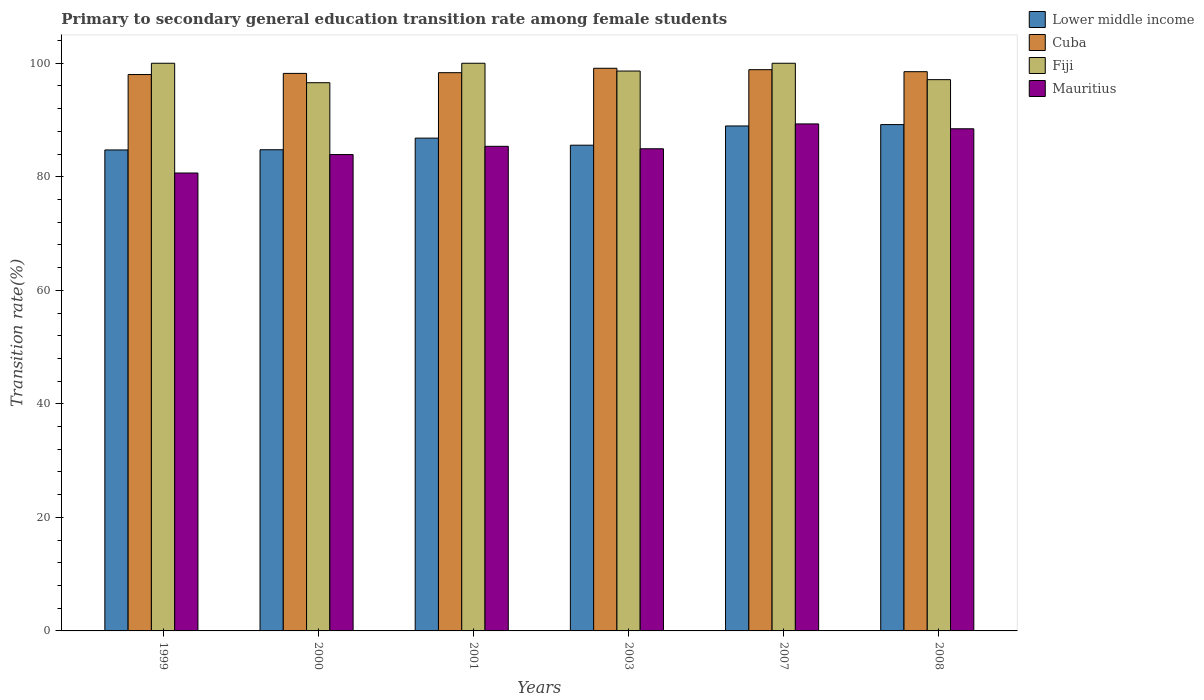How many groups of bars are there?
Keep it short and to the point. 6. Are the number of bars per tick equal to the number of legend labels?
Give a very brief answer. Yes. Are the number of bars on each tick of the X-axis equal?
Provide a short and direct response. Yes. What is the label of the 6th group of bars from the left?
Your response must be concise. 2008. In how many cases, is the number of bars for a given year not equal to the number of legend labels?
Provide a short and direct response. 0. What is the transition rate in Lower middle income in 2008?
Your answer should be compact. 89.2. Across all years, what is the maximum transition rate in Cuba?
Your answer should be very brief. 99.12. Across all years, what is the minimum transition rate in Mauritius?
Ensure brevity in your answer.  80.67. In which year was the transition rate in Lower middle income minimum?
Give a very brief answer. 1999. What is the total transition rate in Cuba in the graph?
Make the answer very short. 591.07. What is the difference between the transition rate in Mauritius in 1999 and that in 2007?
Offer a very short reply. -8.65. What is the difference between the transition rate in Lower middle income in 2001 and the transition rate in Fiji in 1999?
Keep it short and to the point. -13.19. What is the average transition rate in Fiji per year?
Offer a very short reply. 98.72. In the year 2003, what is the difference between the transition rate in Fiji and transition rate in Cuba?
Make the answer very short. -0.49. In how many years, is the transition rate in Lower middle income greater than 60 %?
Offer a terse response. 6. What is the ratio of the transition rate in Fiji in 2000 to that in 2008?
Keep it short and to the point. 0.99. What is the difference between the highest and the second highest transition rate in Mauritius?
Your answer should be compact. 0.86. What is the difference between the highest and the lowest transition rate in Lower middle income?
Offer a very short reply. 4.47. What does the 2nd bar from the left in 2003 represents?
Keep it short and to the point. Cuba. What does the 3rd bar from the right in 2003 represents?
Offer a terse response. Cuba. Is it the case that in every year, the sum of the transition rate in Fiji and transition rate in Cuba is greater than the transition rate in Lower middle income?
Offer a terse response. Yes. How many years are there in the graph?
Provide a short and direct response. 6. What is the difference between two consecutive major ticks on the Y-axis?
Provide a short and direct response. 20. Does the graph contain any zero values?
Your answer should be compact. No. Does the graph contain grids?
Your response must be concise. No. Where does the legend appear in the graph?
Make the answer very short. Top right. How many legend labels are there?
Keep it short and to the point. 4. How are the legend labels stacked?
Your answer should be compact. Vertical. What is the title of the graph?
Make the answer very short. Primary to secondary general education transition rate among female students. What is the label or title of the Y-axis?
Your answer should be compact. Transition rate(%). What is the Transition rate(%) of Lower middle income in 1999?
Ensure brevity in your answer.  84.73. What is the Transition rate(%) of Cuba in 1999?
Give a very brief answer. 98.01. What is the Transition rate(%) of Fiji in 1999?
Ensure brevity in your answer.  100. What is the Transition rate(%) of Mauritius in 1999?
Ensure brevity in your answer.  80.67. What is the Transition rate(%) in Lower middle income in 2000?
Offer a very short reply. 84.76. What is the Transition rate(%) in Cuba in 2000?
Your answer should be very brief. 98.21. What is the Transition rate(%) in Fiji in 2000?
Ensure brevity in your answer.  96.57. What is the Transition rate(%) of Mauritius in 2000?
Make the answer very short. 83.92. What is the Transition rate(%) in Lower middle income in 2001?
Keep it short and to the point. 86.81. What is the Transition rate(%) in Cuba in 2001?
Ensure brevity in your answer.  98.34. What is the Transition rate(%) of Mauritius in 2001?
Keep it short and to the point. 85.37. What is the Transition rate(%) of Lower middle income in 2003?
Give a very brief answer. 85.56. What is the Transition rate(%) of Cuba in 2003?
Offer a very short reply. 99.12. What is the Transition rate(%) in Fiji in 2003?
Make the answer very short. 98.63. What is the Transition rate(%) in Mauritius in 2003?
Ensure brevity in your answer.  84.94. What is the Transition rate(%) in Lower middle income in 2007?
Give a very brief answer. 88.96. What is the Transition rate(%) in Cuba in 2007?
Keep it short and to the point. 98.87. What is the Transition rate(%) in Fiji in 2007?
Your answer should be compact. 100. What is the Transition rate(%) in Mauritius in 2007?
Provide a short and direct response. 89.32. What is the Transition rate(%) in Lower middle income in 2008?
Ensure brevity in your answer.  89.2. What is the Transition rate(%) of Cuba in 2008?
Keep it short and to the point. 98.52. What is the Transition rate(%) in Fiji in 2008?
Offer a terse response. 97.11. What is the Transition rate(%) in Mauritius in 2008?
Provide a short and direct response. 88.46. Across all years, what is the maximum Transition rate(%) of Lower middle income?
Provide a short and direct response. 89.2. Across all years, what is the maximum Transition rate(%) in Cuba?
Your response must be concise. 99.12. Across all years, what is the maximum Transition rate(%) of Mauritius?
Provide a succinct answer. 89.32. Across all years, what is the minimum Transition rate(%) of Lower middle income?
Keep it short and to the point. 84.73. Across all years, what is the minimum Transition rate(%) of Cuba?
Make the answer very short. 98.01. Across all years, what is the minimum Transition rate(%) of Fiji?
Give a very brief answer. 96.57. Across all years, what is the minimum Transition rate(%) of Mauritius?
Offer a very short reply. 80.67. What is the total Transition rate(%) of Lower middle income in the graph?
Keep it short and to the point. 520.02. What is the total Transition rate(%) of Cuba in the graph?
Provide a short and direct response. 591.07. What is the total Transition rate(%) of Fiji in the graph?
Give a very brief answer. 592.31. What is the total Transition rate(%) of Mauritius in the graph?
Your answer should be very brief. 512.66. What is the difference between the Transition rate(%) in Lower middle income in 1999 and that in 2000?
Offer a terse response. -0.04. What is the difference between the Transition rate(%) in Cuba in 1999 and that in 2000?
Your response must be concise. -0.2. What is the difference between the Transition rate(%) of Fiji in 1999 and that in 2000?
Keep it short and to the point. 3.43. What is the difference between the Transition rate(%) in Mauritius in 1999 and that in 2000?
Provide a short and direct response. -3.25. What is the difference between the Transition rate(%) of Lower middle income in 1999 and that in 2001?
Provide a succinct answer. -2.08. What is the difference between the Transition rate(%) of Cuba in 1999 and that in 2001?
Ensure brevity in your answer.  -0.33. What is the difference between the Transition rate(%) in Mauritius in 1999 and that in 2001?
Keep it short and to the point. -4.7. What is the difference between the Transition rate(%) of Lower middle income in 1999 and that in 2003?
Provide a short and direct response. -0.84. What is the difference between the Transition rate(%) of Cuba in 1999 and that in 2003?
Provide a succinct answer. -1.11. What is the difference between the Transition rate(%) of Fiji in 1999 and that in 2003?
Ensure brevity in your answer.  1.37. What is the difference between the Transition rate(%) in Mauritius in 1999 and that in 2003?
Make the answer very short. -4.27. What is the difference between the Transition rate(%) in Lower middle income in 1999 and that in 2007?
Your answer should be compact. -4.23. What is the difference between the Transition rate(%) of Cuba in 1999 and that in 2007?
Provide a short and direct response. -0.86. What is the difference between the Transition rate(%) of Fiji in 1999 and that in 2007?
Keep it short and to the point. 0. What is the difference between the Transition rate(%) in Mauritius in 1999 and that in 2007?
Give a very brief answer. -8.65. What is the difference between the Transition rate(%) of Lower middle income in 1999 and that in 2008?
Provide a succinct answer. -4.47. What is the difference between the Transition rate(%) in Cuba in 1999 and that in 2008?
Your response must be concise. -0.5. What is the difference between the Transition rate(%) in Fiji in 1999 and that in 2008?
Your answer should be very brief. 2.89. What is the difference between the Transition rate(%) of Mauritius in 1999 and that in 2008?
Ensure brevity in your answer.  -7.79. What is the difference between the Transition rate(%) of Lower middle income in 2000 and that in 2001?
Provide a short and direct response. -2.05. What is the difference between the Transition rate(%) of Cuba in 2000 and that in 2001?
Your response must be concise. -0.13. What is the difference between the Transition rate(%) in Fiji in 2000 and that in 2001?
Offer a terse response. -3.43. What is the difference between the Transition rate(%) in Mauritius in 2000 and that in 2001?
Provide a succinct answer. -1.45. What is the difference between the Transition rate(%) in Lower middle income in 2000 and that in 2003?
Make the answer very short. -0.8. What is the difference between the Transition rate(%) in Cuba in 2000 and that in 2003?
Keep it short and to the point. -0.9. What is the difference between the Transition rate(%) in Fiji in 2000 and that in 2003?
Ensure brevity in your answer.  -2.06. What is the difference between the Transition rate(%) of Mauritius in 2000 and that in 2003?
Offer a very short reply. -1.02. What is the difference between the Transition rate(%) in Lower middle income in 2000 and that in 2007?
Your response must be concise. -4.19. What is the difference between the Transition rate(%) of Cuba in 2000 and that in 2007?
Keep it short and to the point. -0.66. What is the difference between the Transition rate(%) in Fiji in 2000 and that in 2007?
Keep it short and to the point. -3.43. What is the difference between the Transition rate(%) of Mauritius in 2000 and that in 2007?
Provide a short and direct response. -5.4. What is the difference between the Transition rate(%) in Lower middle income in 2000 and that in 2008?
Give a very brief answer. -4.43. What is the difference between the Transition rate(%) in Cuba in 2000 and that in 2008?
Your answer should be compact. -0.3. What is the difference between the Transition rate(%) in Fiji in 2000 and that in 2008?
Offer a very short reply. -0.54. What is the difference between the Transition rate(%) of Mauritius in 2000 and that in 2008?
Make the answer very short. -4.54. What is the difference between the Transition rate(%) of Lower middle income in 2001 and that in 2003?
Your answer should be compact. 1.25. What is the difference between the Transition rate(%) in Cuba in 2001 and that in 2003?
Your answer should be very brief. -0.78. What is the difference between the Transition rate(%) of Fiji in 2001 and that in 2003?
Give a very brief answer. 1.37. What is the difference between the Transition rate(%) of Mauritius in 2001 and that in 2003?
Ensure brevity in your answer.  0.43. What is the difference between the Transition rate(%) of Lower middle income in 2001 and that in 2007?
Your answer should be compact. -2.14. What is the difference between the Transition rate(%) in Cuba in 2001 and that in 2007?
Keep it short and to the point. -0.53. What is the difference between the Transition rate(%) of Fiji in 2001 and that in 2007?
Give a very brief answer. 0. What is the difference between the Transition rate(%) of Mauritius in 2001 and that in 2007?
Offer a terse response. -3.95. What is the difference between the Transition rate(%) of Lower middle income in 2001 and that in 2008?
Keep it short and to the point. -2.39. What is the difference between the Transition rate(%) of Cuba in 2001 and that in 2008?
Provide a succinct answer. -0.18. What is the difference between the Transition rate(%) in Fiji in 2001 and that in 2008?
Offer a terse response. 2.89. What is the difference between the Transition rate(%) of Mauritius in 2001 and that in 2008?
Give a very brief answer. -3.09. What is the difference between the Transition rate(%) in Lower middle income in 2003 and that in 2007?
Offer a terse response. -3.39. What is the difference between the Transition rate(%) of Cuba in 2003 and that in 2007?
Your answer should be very brief. 0.25. What is the difference between the Transition rate(%) of Fiji in 2003 and that in 2007?
Your answer should be very brief. -1.37. What is the difference between the Transition rate(%) in Mauritius in 2003 and that in 2007?
Offer a very short reply. -4.38. What is the difference between the Transition rate(%) in Lower middle income in 2003 and that in 2008?
Your answer should be very brief. -3.63. What is the difference between the Transition rate(%) in Cuba in 2003 and that in 2008?
Ensure brevity in your answer.  0.6. What is the difference between the Transition rate(%) of Fiji in 2003 and that in 2008?
Your answer should be very brief. 1.52. What is the difference between the Transition rate(%) of Mauritius in 2003 and that in 2008?
Provide a succinct answer. -3.52. What is the difference between the Transition rate(%) of Lower middle income in 2007 and that in 2008?
Your response must be concise. -0.24. What is the difference between the Transition rate(%) of Cuba in 2007 and that in 2008?
Your answer should be very brief. 0.35. What is the difference between the Transition rate(%) of Fiji in 2007 and that in 2008?
Provide a short and direct response. 2.89. What is the difference between the Transition rate(%) of Mauritius in 2007 and that in 2008?
Offer a terse response. 0.86. What is the difference between the Transition rate(%) of Lower middle income in 1999 and the Transition rate(%) of Cuba in 2000?
Make the answer very short. -13.48. What is the difference between the Transition rate(%) of Lower middle income in 1999 and the Transition rate(%) of Fiji in 2000?
Give a very brief answer. -11.84. What is the difference between the Transition rate(%) of Lower middle income in 1999 and the Transition rate(%) of Mauritius in 2000?
Ensure brevity in your answer.  0.81. What is the difference between the Transition rate(%) of Cuba in 1999 and the Transition rate(%) of Fiji in 2000?
Give a very brief answer. 1.44. What is the difference between the Transition rate(%) of Cuba in 1999 and the Transition rate(%) of Mauritius in 2000?
Provide a succinct answer. 14.1. What is the difference between the Transition rate(%) of Fiji in 1999 and the Transition rate(%) of Mauritius in 2000?
Your response must be concise. 16.08. What is the difference between the Transition rate(%) in Lower middle income in 1999 and the Transition rate(%) in Cuba in 2001?
Keep it short and to the point. -13.61. What is the difference between the Transition rate(%) of Lower middle income in 1999 and the Transition rate(%) of Fiji in 2001?
Make the answer very short. -15.27. What is the difference between the Transition rate(%) in Lower middle income in 1999 and the Transition rate(%) in Mauritius in 2001?
Offer a very short reply. -0.64. What is the difference between the Transition rate(%) in Cuba in 1999 and the Transition rate(%) in Fiji in 2001?
Offer a very short reply. -1.99. What is the difference between the Transition rate(%) of Cuba in 1999 and the Transition rate(%) of Mauritius in 2001?
Offer a terse response. 12.64. What is the difference between the Transition rate(%) of Fiji in 1999 and the Transition rate(%) of Mauritius in 2001?
Keep it short and to the point. 14.63. What is the difference between the Transition rate(%) in Lower middle income in 1999 and the Transition rate(%) in Cuba in 2003?
Give a very brief answer. -14.39. What is the difference between the Transition rate(%) in Lower middle income in 1999 and the Transition rate(%) in Fiji in 2003?
Offer a very short reply. -13.9. What is the difference between the Transition rate(%) of Lower middle income in 1999 and the Transition rate(%) of Mauritius in 2003?
Give a very brief answer. -0.21. What is the difference between the Transition rate(%) in Cuba in 1999 and the Transition rate(%) in Fiji in 2003?
Ensure brevity in your answer.  -0.62. What is the difference between the Transition rate(%) in Cuba in 1999 and the Transition rate(%) in Mauritius in 2003?
Offer a terse response. 13.08. What is the difference between the Transition rate(%) in Fiji in 1999 and the Transition rate(%) in Mauritius in 2003?
Make the answer very short. 15.06. What is the difference between the Transition rate(%) of Lower middle income in 1999 and the Transition rate(%) of Cuba in 2007?
Give a very brief answer. -14.14. What is the difference between the Transition rate(%) in Lower middle income in 1999 and the Transition rate(%) in Fiji in 2007?
Provide a short and direct response. -15.27. What is the difference between the Transition rate(%) of Lower middle income in 1999 and the Transition rate(%) of Mauritius in 2007?
Offer a terse response. -4.59. What is the difference between the Transition rate(%) of Cuba in 1999 and the Transition rate(%) of Fiji in 2007?
Provide a succinct answer. -1.99. What is the difference between the Transition rate(%) in Cuba in 1999 and the Transition rate(%) in Mauritius in 2007?
Keep it short and to the point. 8.7. What is the difference between the Transition rate(%) of Fiji in 1999 and the Transition rate(%) of Mauritius in 2007?
Provide a succinct answer. 10.68. What is the difference between the Transition rate(%) of Lower middle income in 1999 and the Transition rate(%) of Cuba in 2008?
Provide a short and direct response. -13.79. What is the difference between the Transition rate(%) in Lower middle income in 1999 and the Transition rate(%) in Fiji in 2008?
Provide a succinct answer. -12.38. What is the difference between the Transition rate(%) in Lower middle income in 1999 and the Transition rate(%) in Mauritius in 2008?
Your answer should be very brief. -3.73. What is the difference between the Transition rate(%) of Cuba in 1999 and the Transition rate(%) of Fiji in 2008?
Provide a succinct answer. 0.9. What is the difference between the Transition rate(%) of Cuba in 1999 and the Transition rate(%) of Mauritius in 2008?
Your answer should be very brief. 9.55. What is the difference between the Transition rate(%) in Fiji in 1999 and the Transition rate(%) in Mauritius in 2008?
Provide a short and direct response. 11.54. What is the difference between the Transition rate(%) of Lower middle income in 2000 and the Transition rate(%) of Cuba in 2001?
Keep it short and to the point. -13.58. What is the difference between the Transition rate(%) of Lower middle income in 2000 and the Transition rate(%) of Fiji in 2001?
Provide a short and direct response. -15.24. What is the difference between the Transition rate(%) in Lower middle income in 2000 and the Transition rate(%) in Mauritius in 2001?
Ensure brevity in your answer.  -0.6. What is the difference between the Transition rate(%) of Cuba in 2000 and the Transition rate(%) of Fiji in 2001?
Keep it short and to the point. -1.79. What is the difference between the Transition rate(%) in Cuba in 2000 and the Transition rate(%) in Mauritius in 2001?
Keep it short and to the point. 12.85. What is the difference between the Transition rate(%) of Fiji in 2000 and the Transition rate(%) of Mauritius in 2001?
Your answer should be very brief. 11.2. What is the difference between the Transition rate(%) of Lower middle income in 2000 and the Transition rate(%) of Cuba in 2003?
Your answer should be very brief. -14.35. What is the difference between the Transition rate(%) of Lower middle income in 2000 and the Transition rate(%) of Fiji in 2003?
Provide a succinct answer. -13.87. What is the difference between the Transition rate(%) in Lower middle income in 2000 and the Transition rate(%) in Mauritius in 2003?
Your answer should be compact. -0.17. What is the difference between the Transition rate(%) of Cuba in 2000 and the Transition rate(%) of Fiji in 2003?
Offer a terse response. -0.42. What is the difference between the Transition rate(%) of Cuba in 2000 and the Transition rate(%) of Mauritius in 2003?
Keep it short and to the point. 13.28. What is the difference between the Transition rate(%) of Fiji in 2000 and the Transition rate(%) of Mauritius in 2003?
Ensure brevity in your answer.  11.64. What is the difference between the Transition rate(%) of Lower middle income in 2000 and the Transition rate(%) of Cuba in 2007?
Offer a very short reply. -14.11. What is the difference between the Transition rate(%) in Lower middle income in 2000 and the Transition rate(%) in Fiji in 2007?
Your answer should be very brief. -15.24. What is the difference between the Transition rate(%) of Lower middle income in 2000 and the Transition rate(%) of Mauritius in 2007?
Make the answer very short. -4.55. What is the difference between the Transition rate(%) in Cuba in 2000 and the Transition rate(%) in Fiji in 2007?
Your answer should be very brief. -1.79. What is the difference between the Transition rate(%) in Cuba in 2000 and the Transition rate(%) in Mauritius in 2007?
Offer a terse response. 8.9. What is the difference between the Transition rate(%) in Fiji in 2000 and the Transition rate(%) in Mauritius in 2007?
Make the answer very short. 7.26. What is the difference between the Transition rate(%) in Lower middle income in 2000 and the Transition rate(%) in Cuba in 2008?
Keep it short and to the point. -13.75. What is the difference between the Transition rate(%) of Lower middle income in 2000 and the Transition rate(%) of Fiji in 2008?
Give a very brief answer. -12.35. What is the difference between the Transition rate(%) of Lower middle income in 2000 and the Transition rate(%) of Mauritius in 2008?
Provide a short and direct response. -3.69. What is the difference between the Transition rate(%) of Cuba in 2000 and the Transition rate(%) of Fiji in 2008?
Provide a succinct answer. 1.1. What is the difference between the Transition rate(%) in Cuba in 2000 and the Transition rate(%) in Mauritius in 2008?
Your response must be concise. 9.76. What is the difference between the Transition rate(%) of Fiji in 2000 and the Transition rate(%) of Mauritius in 2008?
Your answer should be compact. 8.11. What is the difference between the Transition rate(%) in Lower middle income in 2001 and the Transition rate(%) in Cuba in 2003?
Give a very brief answer. -12.31. What is the difference between the Transition rate(%) of Lower middle income in 2001 and the Transition rate(%) of Fiji in 2003?
Make the answer very short. -11.82. What is the difference between the Transition rate(%) in Lower middle income in 2001 and the Transition rate(%) in Mauritius in 2003?
Offer a terse response. 1.88. What is the difference between the Transition rate(%) of Cuba in 2001 and the Transition rate(%) of Fiji in 2003?
Offer a terse response. -0.29. What is the difference between the Transition rate(%) in Cuba in 2001 and the Transition rate(%) in Mauritius in 2003?
Your answer should be compact. 13.4. What is the difference between the Transition rate(%) of Fiji in 2001 and the Transition rate(%) of Mauritius in 2003?
Make the answer very short. 15.06. What is the difference between the Transition rate(%) in Lower middle income in 2001 and the Transition rate(%) in Cuba in 2007?
Provide a succinct answer. -12.06. What is the difference between the Transition rate(%) in Lower middle income in 2001 and the Transition rate(%) in Fiji in 2007?
Provide a succinct answer. -13.19. What is the difference between the Transition rate(%) of Lower middle income in 2001 and the Transition rate(%) of Mauritius in 2007?
Make the answer very short. -2.5. What is the difference between the Transition rate(%) in Cuba in 2001 and the Transition rate(%) in Fiji in 2007?
Provide a succinct answer. -1.66. What is the difference between the Transition rate(%) of Cuba in 2001 and the Transition rate(%) of Mauritius in 2007?
Your answer should be very brief. 9.02. What is the difference between the Transition rate(%) in Fiji in 2001 and the Transition rate(%) in Mauritius in 2007?
Offer a very short reply. 10.68. What is the difference between the Transition rate(%) of Lower middle income in 2001 and the Transition rate(%) of Cuba in 2008?
Your response must be concise. -11.7. What is the difference between the Transition rate(%) in Lower middle income in 2001 and the Transition rate(%) in Fiji in 2008?
Offer a very short reply. -10.3. What is the difference between the Transition rate(%) of Lower middle income in 2001 and the Transition rate(%) of Mauritius in 2008?
Give a very brief answer. -1.65. What is the difference between the Transition rate(%) of Cuba in 2001 and the Transition rate(%) of Fiji in 2008?
Keep it short and to the point. 1.23. What is the difference between the Transition rate(%) of Cuba in 2001 and the Transition rate(%) of Mauritius in 2008?
Provide a short and direct response. 9.88. What is the difference between the Transition rate(%) in Fiji in 2001 and the Transition rate(%) in Mauritius in 2008?
Ensure brevity in your answer.  11.54. What is the difference between the Transition rate(%) of Lower middle income in 2003 and the Transition rate(%) of Cuba in 2007?
Provide a succinct answer. -13.3. What is the difference between the Transition rate(%) in Lower middle income in 2003 and the Transition rate(%) in Fiji in 2007?
Offer a terse response. -14.44. What is the difference between the Transition rate(%) of Lower middle income in 2003 and the Transition rate(%) of Mauritius in 2007?
Keep it short and to the point. -3.75. What is the difference between the Transition rate(%) in Cuba in 2003 and the Transition rate(%) in Fiji in 2007?
Provide a short and direct response. -0.88. What is the difference between the Transition rate(%) in Cuba in 2003 and the Transition rate(%) in Mauritius in 2007?
Make the answer very short. 9.8. What is the difference between the Transition rate(%) of Fiji in 2003 and the Transition rate(%) of Mauritius in 2007?
Give a very brief answer. 9.31. What is the difference between the Transition rate(%) of Lower middle income in 2003 and the Transition rate(%) of Cuba in 2008?
Provide a short and direct response. -12.95. What is the difference between the Transition rate(%) of Lower middle income in 2003 and the Transition rate(%) of Fiji in 2008?
Keep it short and to the point. -11.55. What is the difference between the Transition rate(%) in Lower middle income in 2003 and the Transition rate(%) in Mauritius in 2008?
Your answer should be very brief. -2.89. What is the difference between the Transition rate(%) of Cuba in 2003 and the Transition rate(%) of Fiji in 2008?
Provide a short and direct response. 2.01. What is the difference between the Transition rate(%) of Cuba in 2003 and the Transition rate(%) of Mauritius in 2008?
Your answer should be compact. 10.66. What is the difference between the Transition rate(%) in Fiji in 2003 and the Transition rate(%) in Mauritius in 2008?
Ensure brevity in your answer.  10.17. What is the difference between the Transition rate(%) of Lower middle income in 2007 and the Transition rate(%) of Cuba in 2008?
Your answer should be compact. -9.56. What is the difference between the Transition rate(%) of Lower middle income in 2007 and the Transition rate(%) of Fiji in 2008?
Offer a very short reply. -8.16. What is the difference between the Transition rate(%) in Lower middle income in 2007 and the Transition rate(%) in Mauritius in 2008?
Offer a very short reply. 0.5. What is the difference between the Transition rate(%) in Cuba in 2007 and the Transition rate(%) in Fiji in 2008?
Offer a terse response. 1.76. What is the difference between the Transition rate(%) of Cuba in 2007 and the Transition rate(%) of Mauritius in 2008?
Your answer should be compact. 10.41. What is the difference between the Transition rate(%) of Fiji in 2007 and the Transition rate(%) of Mauritius in 2008?
Give a very brief answer. 11.54. What is the average Transition rate(%) in Lower middle income per year?
Make the answer very short. 86.67. What is the average Transition rate(%) of Cuba per year?
Your response must be concise. 98.51. What is the average Transition rate(%) of Fiji per year?
Keep it short and to the point. 98.72. What is the average Transition rate(%) in Mauritius per year?
Offer a very short reply. 85.44. In the year 1999, what is the difference between the Transition rate(%) of Lower middle income and Transition rate(%) of Cuba?
Give a very brief answer. -13.28. In the year 1999, what is the difference between the Transition rate(%) of Lower middle income and Transition rate(%) of Fiji?
Keep it short and to the point. -15.27. In the year 1999, what is the difference between the Transition rate(%) in Lower middle income and Transition rate(%) in Mauritius?
Your answer should be very brief. 4.06. In the year 1999, what is the difference between the Transition rate(%) in Cuba and Transition rate(%) in Fiji?
Your answer should be compact. -1.99. In the year 1999, what is the difference between the Transition rate(%) of Cuba and Transition rate(%) of Mauritius?
Give a very brief answer. 17.35. In the year 1999, what is the difference between the Transition rate(%) in Fiji and Transition rate(%) in Mauritius?
Offer a terse response. 19.33. In the year 2000, what is the difference between the Transition rate(%) of Lower middle income and Transition rate(%) of Cuba?
Your answer should be very brief. -13.45. In the year 2000, what is the difference between the Transition rate(%) of Lower middle income and Transition rate(%) of Fiji?
Your answer should be very brief. -11.81. In the year 2000, what is the difference between the Transition rate(%) in Lower middle income and Transition rate(%) in Mauritius?
Your answer should be compact. 0.85. In the year 2000, what is the difference between the Transition rate(%) in Cuba and Transition rate(%) in Fiji?
Your answer should be compact. 1.64. In the year 2000, what is the difference between the Transition rate(%) of Cuba and Transition rate(%) of Mauritius?
Provide a short and direct response. 14.3. In the year 2000, what is the difference between the Transition rate(%) of Fiji and Transition rate(%) of Mauritius?
Provide a succinct answer. 12.66. In the year 2001, what is the difference between the Transition rate(%) of Lower middle income and Transition rate(%) of Cuba?
Provide a short and direct response. -11.53. In the year 2001, what is the difference between the Transition rate(%) of Lower middle income and Transition rate(%) of Fiji?
Give a very brief answer. -13.19. In the year 2001, what is the difference between the Transition rate(%) of Lower middle income and Transition rate(%) of Mauritius?
Your response must be concise. 1.44. In the year 2001, what is the difference between the Transition rate(%) of Cuba and Transition rate(%) of Fiji?
Give a very brief answer. -1.66. In the year 2001, what is the difference between the Transition rate(%) of Cuba and Transition rate(%) of Mauritius?
Keep it short and to the point. 12.97. In the year 2001, what is the difference between the Transition rate(%) of Fiji and Transition rate(%) of Mauritius?
Provide a succinct answer. 14.63. In the year 2003, what is the difference between the Transition rate(%) in Lower middle income and Transition rate(%) in Cuba?
Give a very brief answer. -13.55. In the year 2003, what is the difference between the Transition rate(%) of Lower middle income and Transition rate(%) of Fiji?
Give a very brief answer. -13.06. In the year 2003, what is the difference between the Transition rate(%) in Lower middle income and Transition rate(%) in Mauritius?
Offer a terse response. 0.63. In the year 2003, what is the difference between the Transition rate(%) in Cuba and Transition rate(%) in Fiji?
Your answer should be very brief. 0.49. In the year 2003, what is the difference between the Transition rate(%) in Cuba and Transition rate(%) in Mauritius?
Ensure brevity in your answer.  14.18. In the year 2003, what is the difference between the Transition rate(%) of Fiji and Transition rate(%) of Mauritius?
Provide a succinct answer. 13.69. In the year 2007, what is the difference between the Transition rate(%) in Lower middle income and Transition rate(%) in Cuba?
Your response must be concise. -9.91. In the year 2007, what is the difference between the Transition rate(%) in Lower middle income and Transition rate(%) in Fiji?
Keep it short and to the point. -11.04. In the year 2007, what is the difference between the Transition rate(%) in Lower middle income and Transition rate(%) in Mauritius?
Give a very brief answer. -0.36. In the year 2007, what is the difference between the Transition rate(%) of Cuba and Transition rate(%) of Fiji?
Ensure brevity in your answer.  -1.13. In the year 2007, what is the difference between the Transition rate(%) in Cuba and Transition rate(%) in Mauritius?
Ensure brevity in your answer.  9.55. In the year 2007, what is the difference between the Transition rate(%) of Fiji and Transition rate(%) of Mauritius?
Your response must be concise. 10.68. In the year 2008, what is the difference between the Transition rate(%) in Lower middle income and Transition rate(%) in Cuba?
Your response must be concise. -9.32. In the year 2008, what is the difference between the Transition rate(%) in Lower middle income and Transition rate(%) in Fiji?
Offer a very short reply. -7.91. In the year 2008, what is the difference between the Transition rate(%) in Lower middle income and Transition rate(%) in Mauritius?
Your answer should be compact. 0.74. In the year 2008, what is the difference between the Transition rate(%) of Cuba and Transition rate(%) of Fiji?
Provide a succinct answer. 1.4. In the year 2008, what is the difference between the Transition rate(%) of Cuba and Transition rate(%) of Mauritius?
Your answer should be compact. 10.06. In the year 2008, what is the difference between the Transition rate(%) of Fiji and Transition rate(%) of Mauritius?
Provide a short and direct response. 8.65. What is the ratio of the Transition rate(%) in Fiji in 1999 to that in 2000?
Your answer should be compact. 1.04. What is the ratio of the Transition rate(%) in Mauritius in 1999 to that in 2000?
Your answer should be very brief. 0.96. What is the ratio of the Transition rate(%) of Cuba in 1999 to that in 2001?
Keep it short and to the point. 1. What is the ratio of the Transition rate(%) in Mauritius in 1999 to that in 2001?
Your answer should be compact. 0.94. What is the ratio of the Transition rate(%) of Lower middle income in 1999 to that in 2003?
Your answer should be very brief. 0.99. What is the ratio of the Transition rate(%) in Cuba in 1999 to that in 2003?
Provide a short and direct response. 0.99. What is the ratio of the Transition rate(%) of Fiji in 1999 to that in 2003?
Provide a succinct answer. 1.01. What is the ratio of the Transition rate(%) of Mauritius in 1999 to that in 2003?
Your answer should be very brief. 0.95. What is the ratio of the Transition rate(%) of Lower middle income in 1999 to that in 2007?
Make the answer very short. 0.95. What is the ratio of the Transition rate(%) of Cuba in 1999 to that in 2007?
Your answer should be very brief. 0.99. What is the ratio of the Transition rate(%) in Mauritius in 1999 to that in 2007?
Keep it short and to the point. 0.9. What is the ratio of the Transition rate(%) of Lower middle income in 1999 to that in 2008?
Provide a succinct answer. 0.95. What is the ratio of the Transition rate(%) of Cuba in 1999 to that in 2008?
Ensure brevity in your answer.  0.99. What is the ratio of the Transition rate(%) in Fiji in 1999 to that in 2008?
Your answer should be compact. 1.03. What is the ratio of the Transition rate(%) in Mauritius in 1999 to that in 2008?
Offer a terse response. 0.91. What is the ratio of the Transition rate(%) of Lower middle income in 2000 to that in 2001?
Provide a succinct answer. 0.98. What is the ratio of the Transition rate(%) in Fiji in 2000 to that in 2001?
Ensure brevity in your answer.  0.97. What is the ratio of the Transition rate(%) in Mauritius in 2000 to that in 2001?
Your answer should be very brief. 0.98. What is the ratio of the Transition rate(%) in Lower middle income in 2000 to that in 2003?
Your answer should be very brief. 0.99. What is the ratio of the Transition rate(%) in Cuba in 2000 to that in 2003?
Provide a short and direct response. 0.99. What is the ratio of the Transition rate(%) in Fiji in 2000 to that in 2003?
Provide a succinct answer. 0.98. What is the ratio of the Transition rate(%) in Lower middle income in 2000 to that in 2007?
Offer a very short reply. 0.95. What is the ratio of the Transition rate(%) in Cuba in 2000 to that in 2007?
Give a very brief answer. 0.99. What is the ratio of the Transition rate(%) of Fiji in 2000 to that in 2007?
Give a very brief answer. 0.97. What is the ratio of the Transition rate(%) of Mauritius in 2000 to that in 2007?
Offer a terse response. 0.94. What is the ratio of the Transition rate(%) of Lower middle income in 2000 to that in 2008?
Ensure brevity in your answer.  0.95. What is the ratio of the Transition rate(%) of Mauritius in 2000 to that in 2008?
Provide a short and direct response. 0.95. What is the ratio of the Transition rate(%) of Lower middle income in 2001 to that in 2003?
Make the answer very short. 1.01. What is the ratio of the Transition rate(%) in Fiji in 2001 to that in 2003?
Offer a terse response. 1.01. What is the ratio of the Transition rate(%) in Mauritius in 2001 to that in 2003?
Make the answer very short. 1.01. What is the ratio of the Transition rate(%) of Lower middle income in 2001 to that in 2007?
Keep it short and to the point. 0.98. What is the ratio of the Transition rate(%) in Mauritius in 2001 to that in 2007?
Provide a short and direct response. 0.96. What is the ratio of the Transition rate(%) of Lower middle income in 2001 to that in 2008?
Your answer should be very brief. 0.97. What is the ratio of the Transition rate(%) of Cuba in 2001 to that in 2008?
Your answer should be compact. 1. What is the ratio of the Transition rate(%) in Fiji in 2001 to that in 2008?
Your answer should be compact. 1.03. What is the ratio of the Transition rate(%) in Mauritius in 2001 to that in 2008?
Ensure brevity in your answer.  0.97. What is the ratio of the Transition rate(%) in Lower middle income in 2003 to that in 2007?
Make the answer very short. 0.96. What is the ratio of the Transition rate(%) of Cuba in 2003 to that in 2007?
Offer a terse response. 1. What is the ratio of the Transition rate(%) in Fiji in 2003 to that in 2007?
Give a very brief answer. 0.99. What is the ratio of the Transition rate(%) in Mauritius in 2003 to that in 2007?
Provide a succinct answer. 0.95. What is the ratio of the Transition rate(%) of Lower middle income in 2003 to that in 2008?
Provide a short and direct response. 0.96. What is the ratio of the Transition rate(%) in Fiji in 2003 to that in 2008?
Offer a terse response. 1.02. What is the ratio of the Transition rate(%) in Mauritius in 2003 to that in 2008?
Provide a short and direct response. 0.96. What is the ratio of the Transition rate(%) of Cuba in 2007 to that in 2008?
Ensure brevity in your answer.  1. What is the ratio of the Transition rate(%) in Fiji in 2007 to that in 2008?
Offer a terse response. 1.03. What is the ratio of the Transition rate(%) of Mauritius in 2007 to that in 2008?
Your answer should be very brief. 1.01. What is the difference between the highest and the second highest Transition rate(%) of Lower middle income?
Your answer should be very brief. 0.24. What is the difference between the highest and the second highest Transition rate(%) of Cuba?
Provide a short and direct response. 0.25. What is the difference between the highest and the second highest Transition rate(%) in Mauritius?
Provide a succinct answer. 0.86. What is the difference between the highest and the lowest Transition rate(%) of Lower middle income?
Give a very brief answer. 4.47. What is the difference between the highest and the lowest Transition rate(%) in Cuba?
Make the answer very short. 1.11. What is the difference between the highest and the lowest Transition rate(%) in Fiji?
Provide a short and direct response. 3.43. What is the difference between the highest and the lowest Transition rate(%) in Mauritius?
Provide a succinct answer. 8.65. 